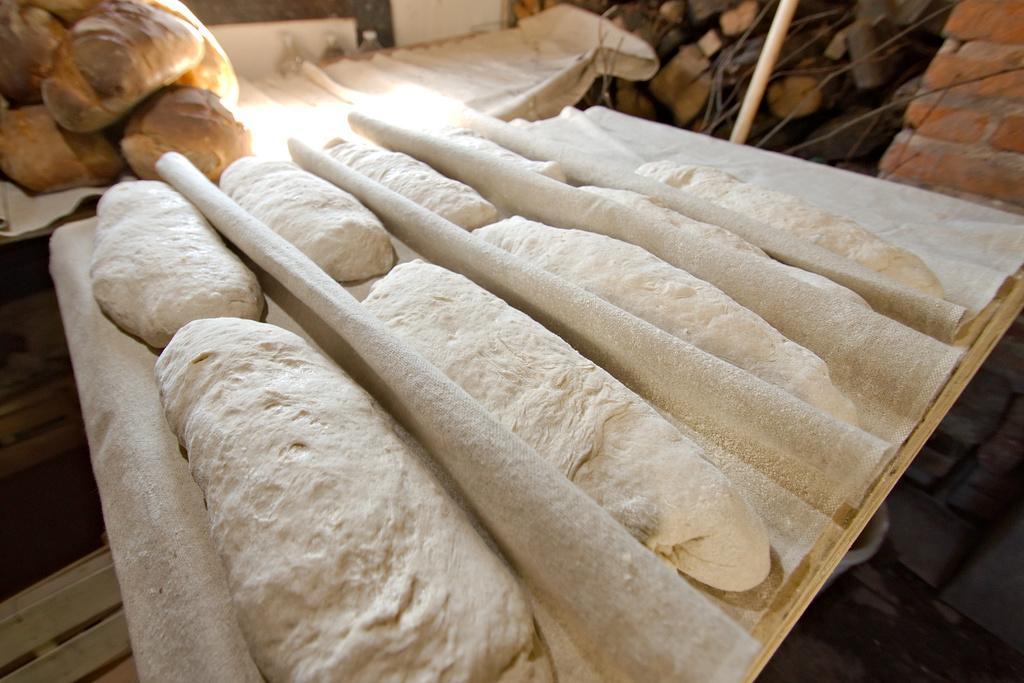Describe this image in one or two sentences. In this picture we can see clothes, food items, bottles, wooden logs, pole, wall and some objects. 